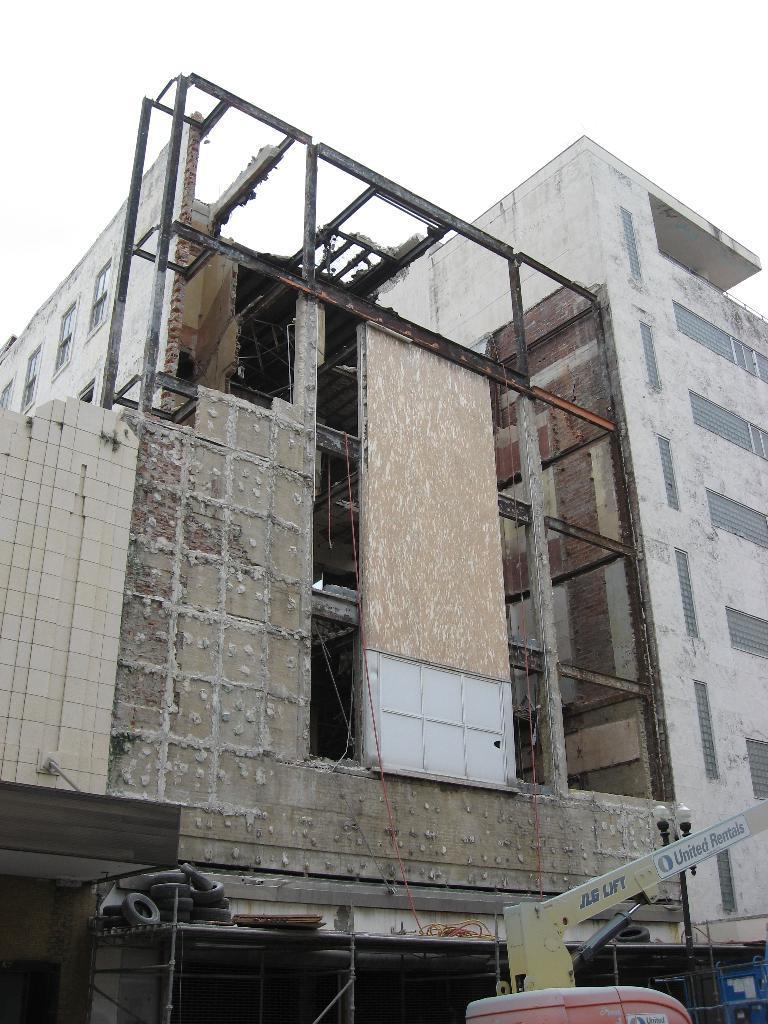How would you summarize this image in a sentence or two? In this image, there is an outside view. There is building in the middle of the image. There is a sky at the top of the image. 